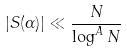<formula> <loc_0><loc_0><loc_500><loc_500>| S ( \alpha ) | \ll \frac { N } { \log ^ { A } N }</formula> 